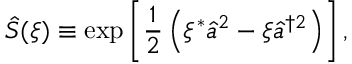Convert formula to latex. <formula><loc_0><loc_0><loc_500><loc_500>\hat { S } ( \xi ) \equiv \exp \left [ \frac { 1 } { 2 } \left ( \xi ^ { * } \hat { a } ^ { 2 } - \xi \hat { a } ^ { \dagger 2 } \right ) \right ] ,</formula> 